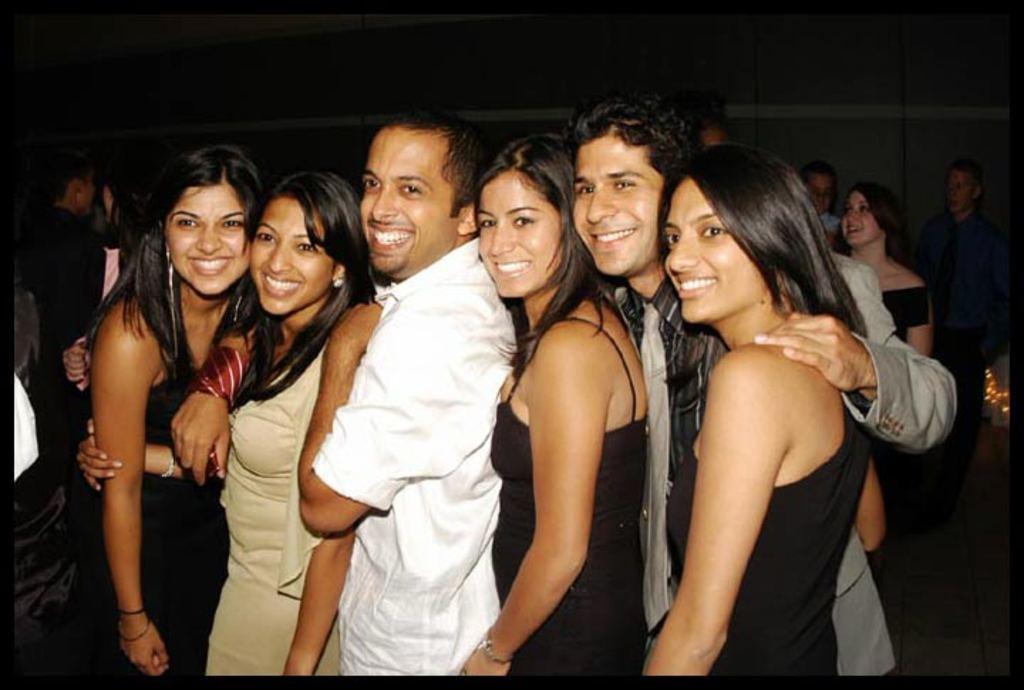Describe this image in one or two sentences. In this image we can see some people standing in a row. In the background we can see the other persons standing on the floor. 